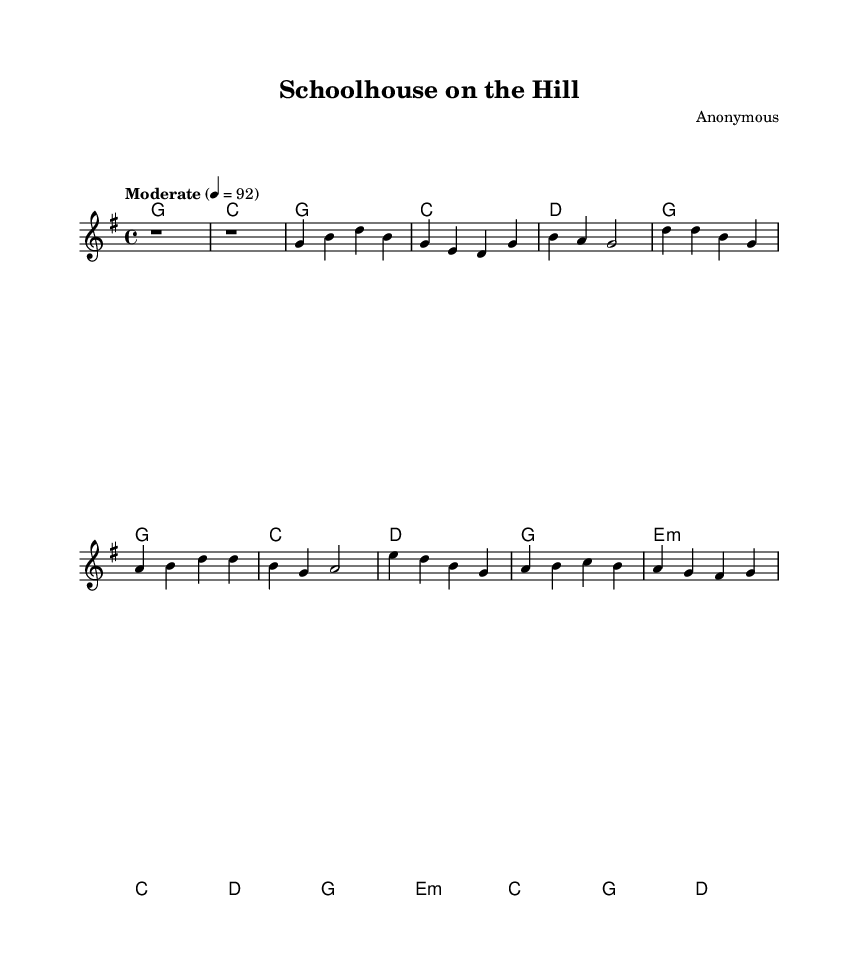What is the key signature of this music? The key signature is G major, which has one sharp (F#). This can be identified by looking at the beginning of the staff where the sharp is notated.
Answer: G major What is the time signature of this piece? The time signature is 4/4, indicated at the beginning of the staff. This means there are four beats in each measure and the quarter note gets one beat.
Answer: 4/4 What is the tempo marking for this piece? The tempo marking is "Moderate" set at 92 beats per minute. This is displayed above the staff in the tempo settings section.
Answer: Moderate 92 How many measures are in the verse section? The verse section consists of three measures. You can count the measures that contain the melody line notated above the chord changes in the score.
Answer: 3 What chord is played in the bridge section? The bridge section features an E minor chord in the first measure of that section, as indicated by its notation in the chord mode.
Answer: E minor What is the structure of the song based on the sections? The structure includes an Intro, Verse, Chorus, and Bridge. You can determine this by examining the distinct sections labeled within the score.
Answer: Intro, Verse, Chorus, Bridge How many chords are used in the chorus? The chorus section uses four chords: G, C, D, and E minor. This is determined by looking at the chord changes listed in the chord mode for that part of the song.
Answer: 4 